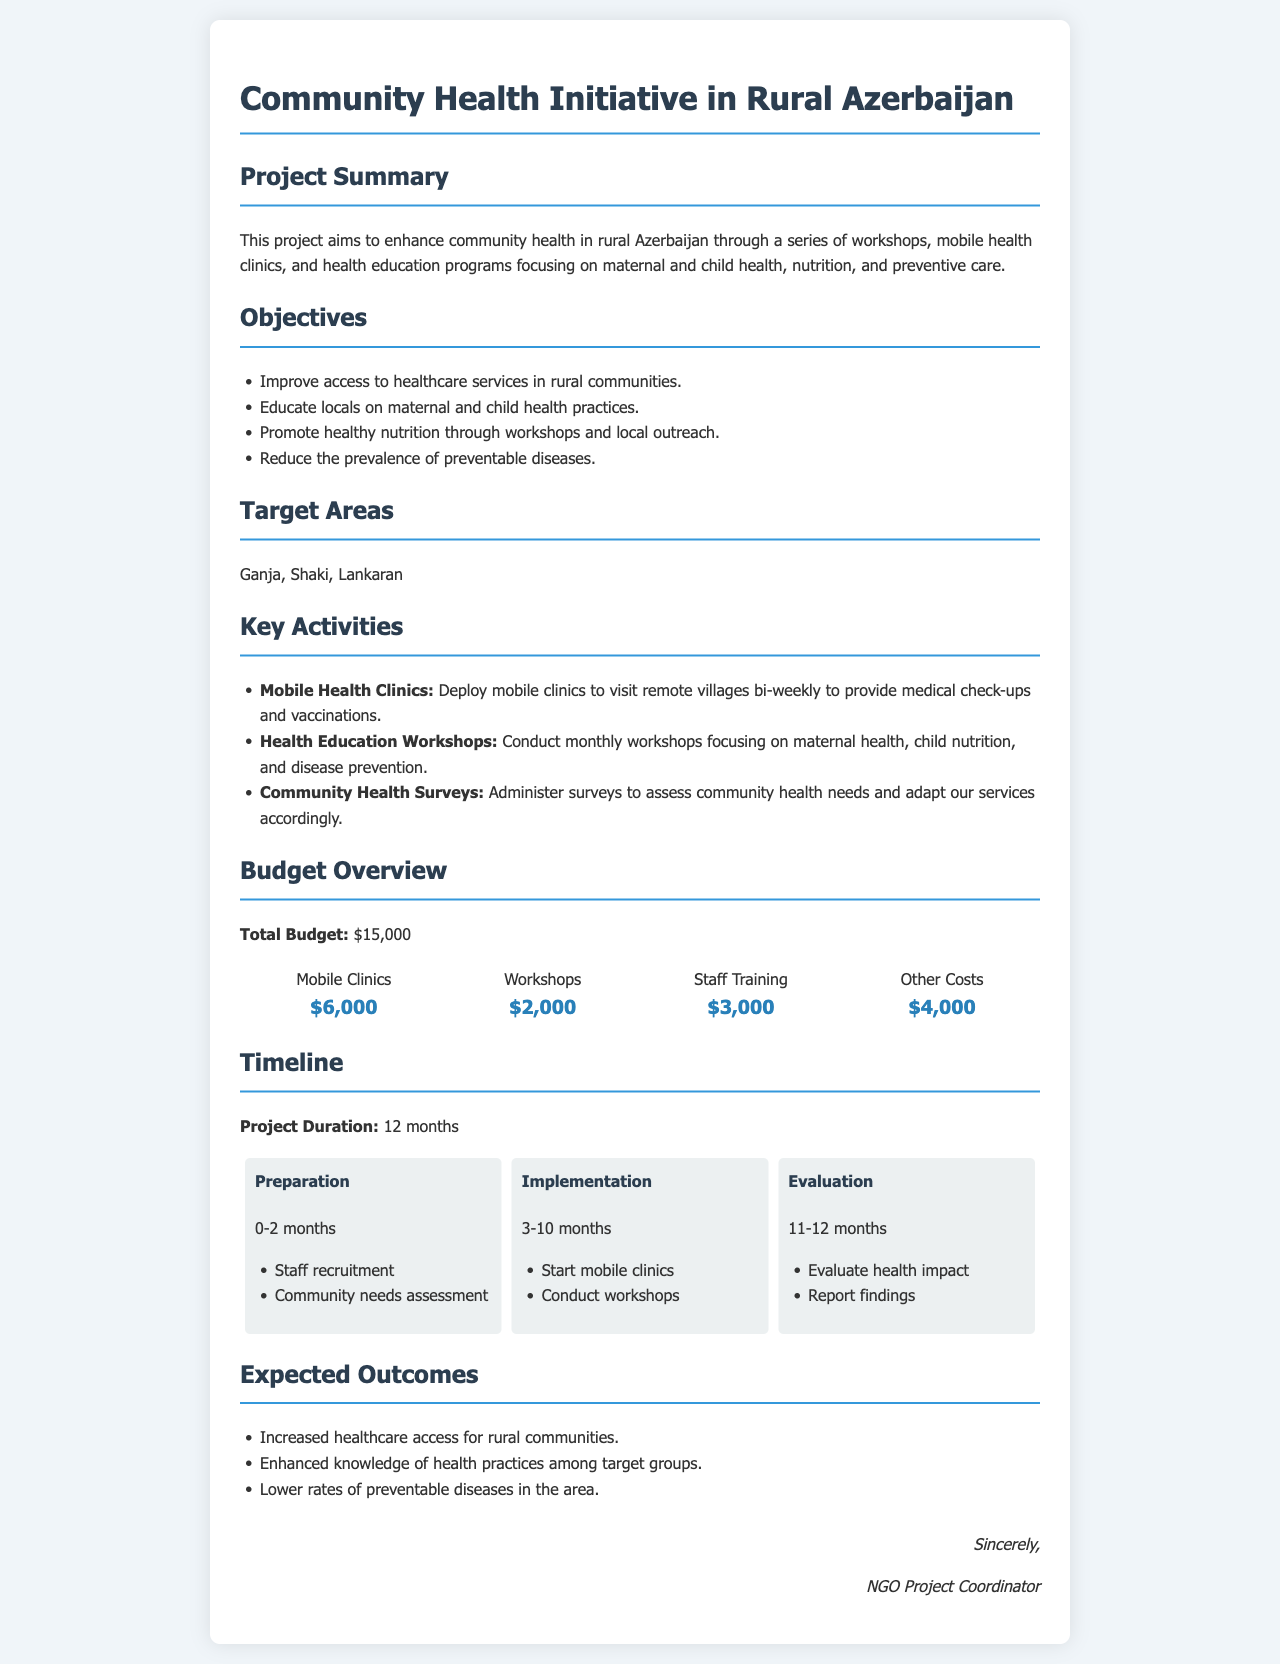What is the total budget for the project? The total budget is explicitly stated in the document under the budget overview section.
Answer: $15,000 What are the target areas for the initiative? The document lists specific areas targeted by the project in the target areas section.
Answer: Ganja, Shaki, Lankaran How many months will the project last? The project duration is clearly mentioned in the timeline section of the document.
Answer: 12 months What activity will take place bi-weekly? The document describes an activity that occurs bi-weekly in the key activities section.
Answer: Mobile Health Clinics What phase involves staff recruitment? The timeline section indicates the phase where staff recruitment is included.
Answer: Preparation What is the budget allocation for workshops? The budget overview specifies the amount allocated for workshops.
Answer: $2,000 What is one expected outcome of the project? The document lists multiple expected outcomes in the expected outcomes section.
Answer: Increased healthcare access for rural communities During which months is the implementation phase scheduled? The document outlines the months designated for the implementation phase in the timeline section.
Answer: 3-10 months 